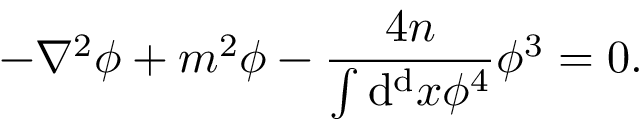<formula> <loc_0><loc_0><loc_500><loc_500>- \nabla ^ { 2 } \phi + m ^ { 2 } \phi - { \frac { 4 n } { \int d ^ { d } x \phi ^ { 4 } } } \phi ^ { 3 } = 0 .</formula> 